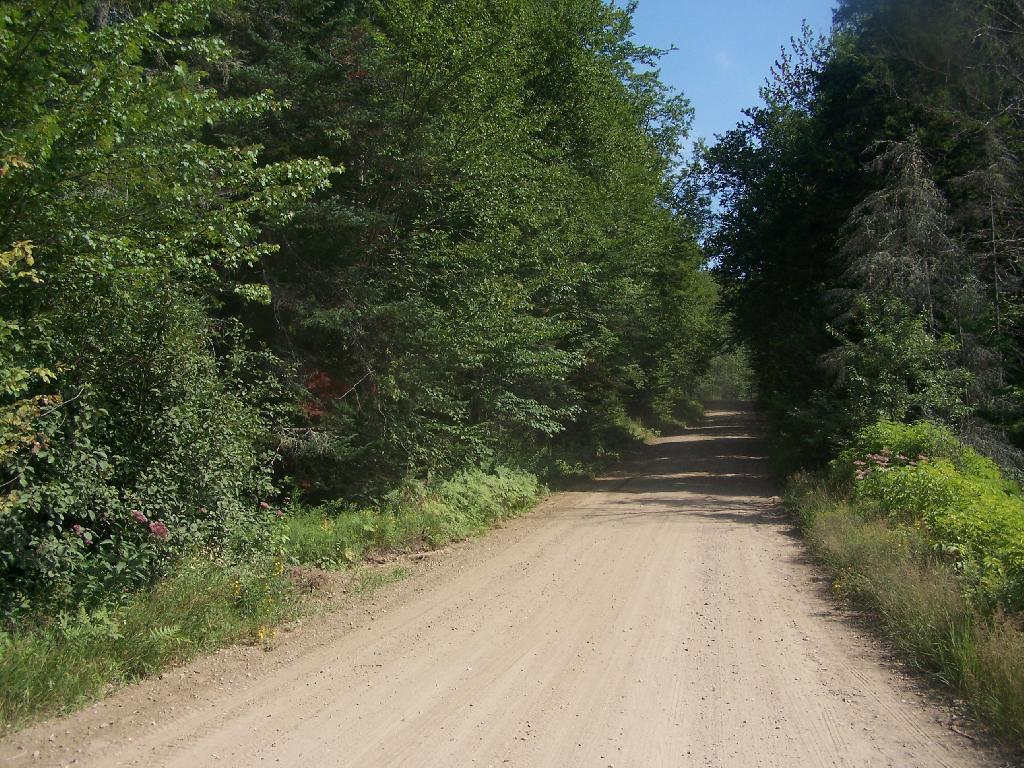Describe this image in one or two sentences. In the center of the image we can see the sky,trees,plants,grass and road. 